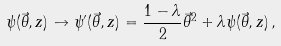Convert formula to latex. <formula><loc_0><loc_0><loc_500><loc_500>\psi ( \vec { \theta } , z ) \to \psi ^ { \prime } ( \vec { \theta } , z ) = \frac { 1 - \lambda } { 2 } \vec { \theta } ^ { 2 } + \lambda \psi ( \vec { \theta } , z ) \, ,</formula> 